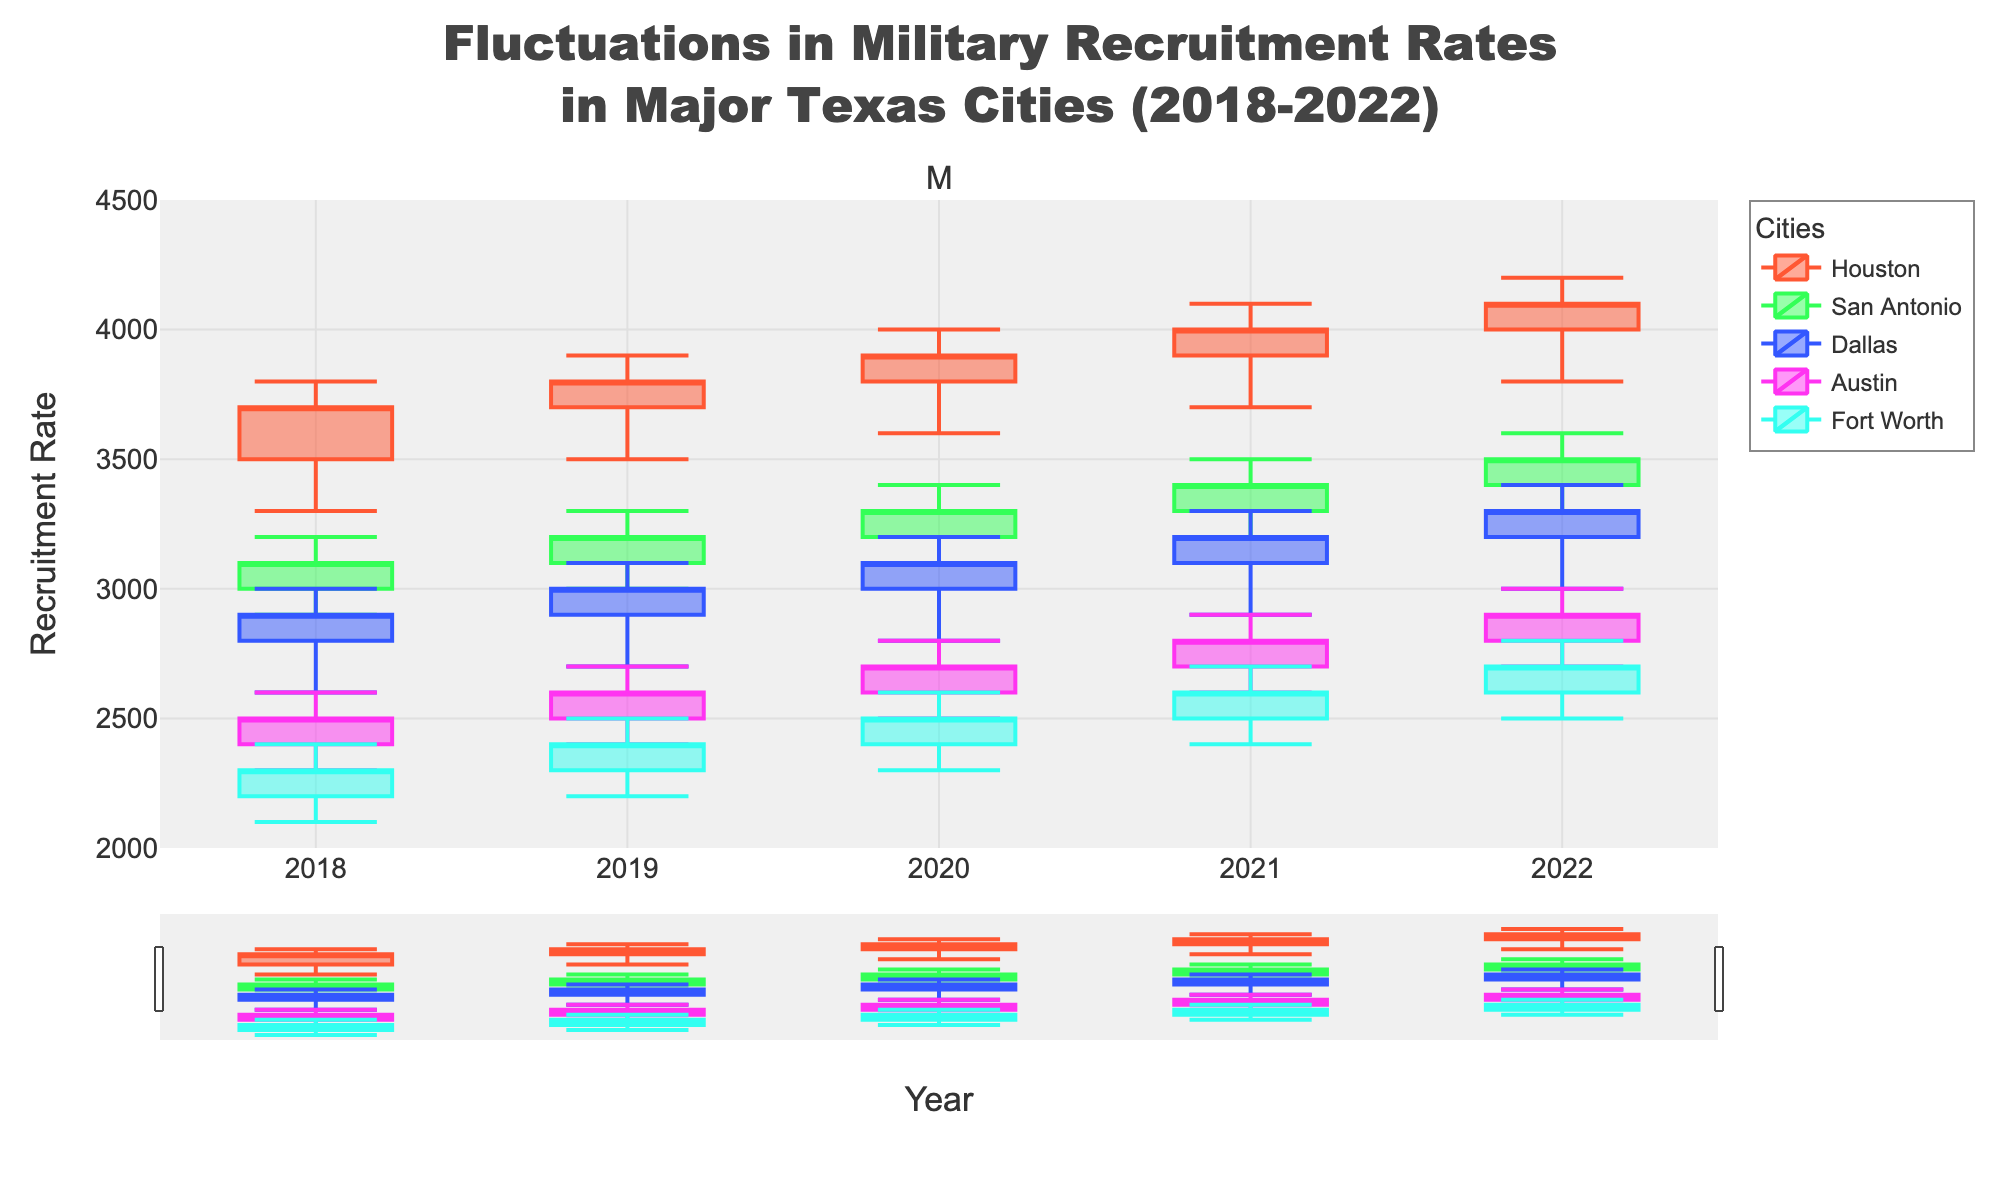What is the title of the plot? The title is usually located at the top of the plot. In this case, the title reads, "Fluctuations in Military Recruitment Rates in Major Texas Cities (2018-2022)."
Answer: Fluctuations in Military Recruitment Rates in Major Texas Cities (2018-2022) Which city had the highest recruitment rate in 2022? By visually inspecting the candlesticks for each city in 2022, we observe that Houston has the highest "High" value among the cities.
Answer: Houston Did any city show a decrease in its closing recruitment rate from 2018 to 2022? Checking the closing values for each city in 2018 and 2022, we can see that none of the cities had a lower closing value in 2022 compared to 2018.
Answer: No What was the range of recruitment rates for San Antonio in 2019? The range is determined by the highest and lowest values of the candlestick for 2019. San Antonio had a High of 3300 and a Low of 3000. Therefore, the range was 3300 - 3000.
Answer: 300 Which city showed the most significant increase in closing recruitment rates from 2018 to 2022? To determine the most significant increase, compare the closing values for each city from 2018 to 2022. Houston's closing rate increased from 3700 in 2018 to 4100 in 2022, which is a 400-point increase. Other cities had less significant increases.
Answer: Houston In which year did Dallas experience its lowest low, and what was the value? Inspect the candlesticks for Dallas across all years to spot the lowest point. The lowest low for Dallas occurred in 2018 with a value of 2600.
Answer: 2018, 2600 Which two cities had similar recruitment rate trends over the five years? Observing the overall shapes and patterns of the candlesticks for each city over the five years, both San Antonio and Fort Worth show similar trends with increasing recruitment rates and similar volatility patterns.
Answer: San Antonio and Fort Worth How did Austin's recruitment rate change from 2020 to 2021? Comparing the candlesticks for Austin between 2020 and 2021 shows that the closing value increased from 2700 to 2800.
Answer: Increased by 100 What was the average opening recruitment rate for Houston from 2018 to 2022? Sum the opening rates for Houston from 2018 to 2022 (3500 + 3700 + 3800 + 3900 + 4000) and divide by 5. (3500 + 3700 + 3800 + 3900 + 4000) / 5 = 3780.
Answer: 3780 Which city had the widest candlestick range in 2020, and what does it imply? The widest range is identified by the largest gap between the high and low values. Houston has the widest range in 2020 (4000 - 3600 = 400), indicating significant fluctuation in recruitment rates.
Answer: Houston, indicates high fluctuation 